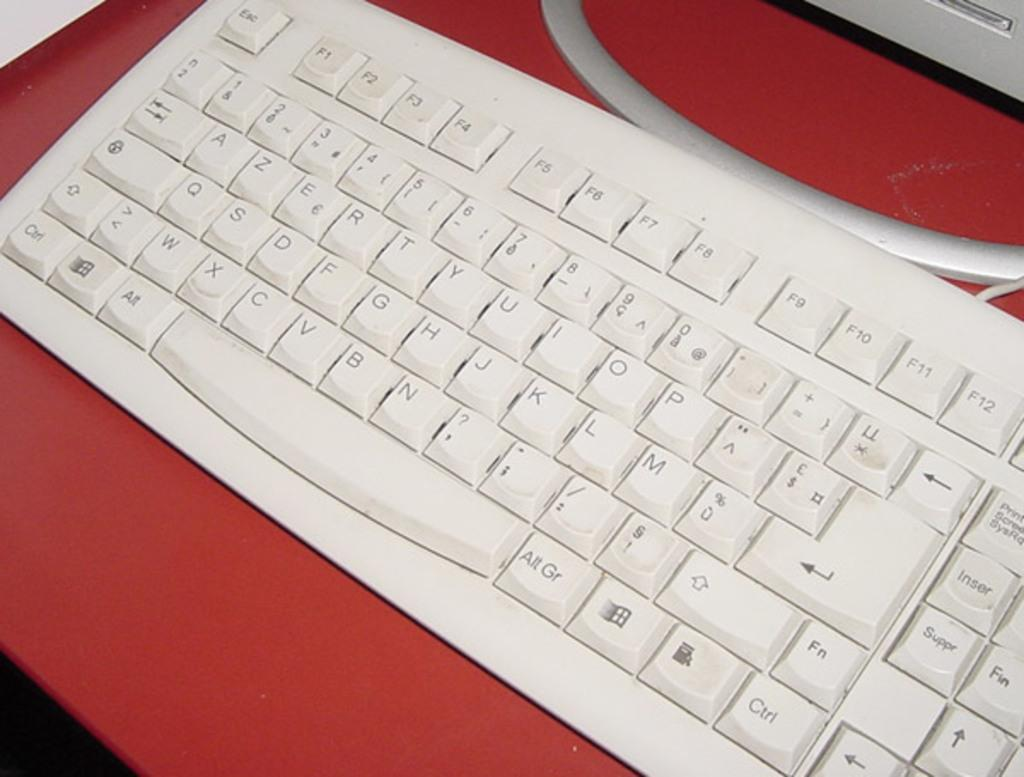Provide a one-sentence caption for the provided image. A white keyboard has an Alt key and an Alt Gr key on either side of the space bar. 